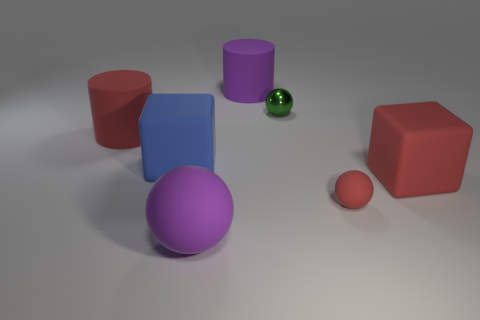Add 2 large red shiny things. How many objects exist? 9 Subtract all small matte balls. How many balls are left? 2 Subtract 1 green spheres. How many objects are left? 6 Subtract all cylinders. How many objects are left? 5 Subtract 2 cylinders. How many cylinders are left? 0 Subtract all purple cubes. Subtract all yellow spheres. How many cubes are left? 2 Subtract all green blocks. How many brown spheres are left? 0 Subtract all large purple matte cylinders. Subtract all green metallic spheres. How many objects are left? 5 Add 4 big purple things. How many big purple things are left? 6 Add 1 metallic spheres. How many metallic spheres exist? 2 